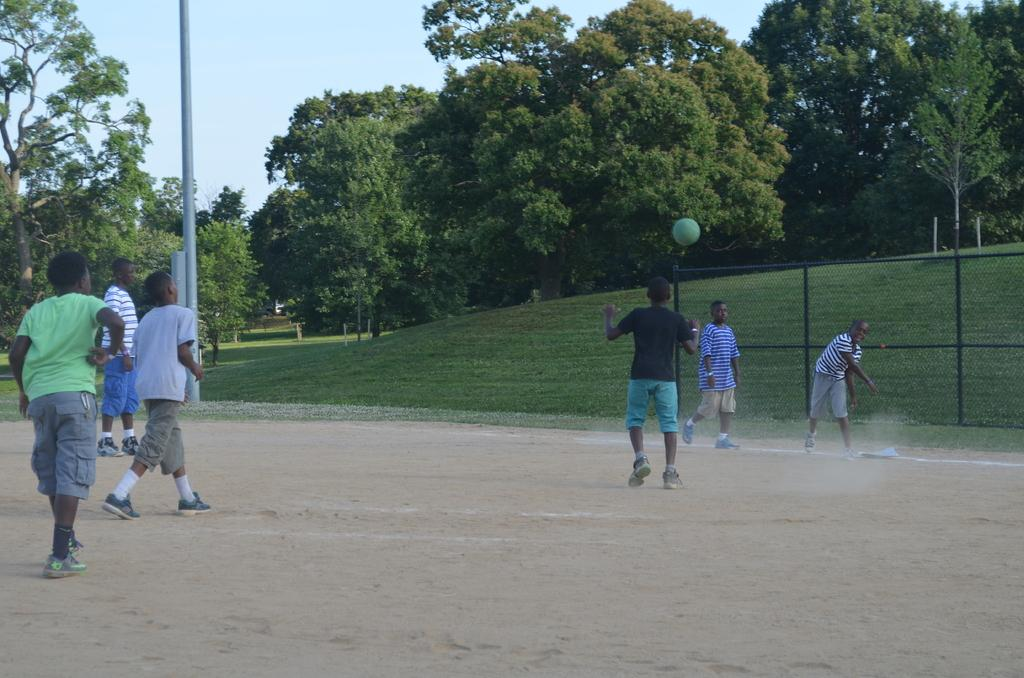Who is present in the image? There are children in the image. What are the children doing in the image? The children are playing on the ground. What type of surface can be seen in the background? There is a grass surface in the background. What other natural elements are visible in the background? There are trees in the background. What type of cherries can be seen growing on the trees in the image? There are no cherries present in the image, and the trees do not appear to be fruit-bearing trees. What is being served for lunch in the image? There is no indication of lunch being served in the image; the focus is on the children playing on the ground. 